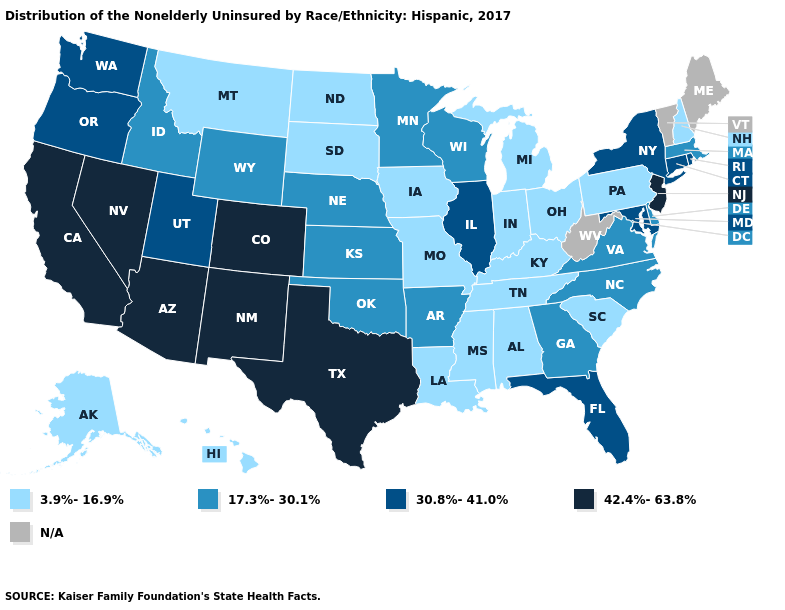Does the map have missing data?
Concise answer only. Yes. Name the states that have a value in the range 3.9%-16.9%?
Answer briefly. Alabama, Alaska, Hawaii, Indiana, Iowa, Kentucky, Louisiana, Michigan, Mississippi, Missouri, Montana, New Hampshire, North Dakota, Ohio, Pennsylvania, South Carolina, South Dakota, Tennessee. Is the legend a continuous bar?
Give a very brief answer. No. What is the highest value in the USA?
Quick response, please. 42.4%-63.8%. What is the highest value in the USA?
Short answer required. 42.4%-63.8%. Which states have the lowest value in the South?
Answer briefly. Alabama, Kentucky, Louisiana, Mississippi, South Carolina, Tennessee. What is the value of North Dakota?
Write a very short answer. 3.9%-16.9%. Which states have the highest value in the USA?
Short answer required. Arizona, California, Colorado, Nevada, New Jersey, New Mexico, Texas. What is the highest value in the South ?
Be succinct. 42.4%-63.8%. Does Wyoming have the lowest value in the USA?
Answer briefly. No. Among the states that border New Jersey , does Delaware have the lowest value?
Be succinct. No. Which states hav the highest value in the South?
Be succinct. Texas. 